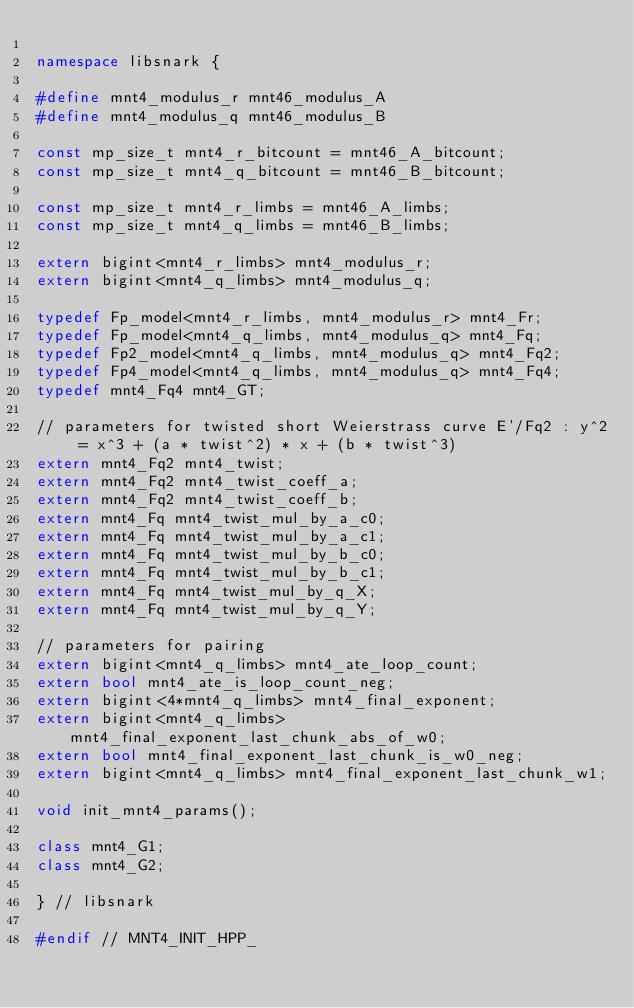<code> <loc_0><loc_0><loc_500><loc_500><_C++_>
namespace libsnark {

#define mnt4_modulus_r mnt46_modulus_A
#define mnt4_modulus_q mnt46_modulus_B

const mp_size_t mnt4_r_bitcount = mnt46_A_bitcount;
const mp_size_t mnt4_q_bitcount = mnt46_B_bitcount;

const mp_size_t mnt4_r_limbs = mnt46_A_limbs;
const mp_size_t mnt4_q_limbs = mnt46_B_limbs;

extern bigint<mnt4_r_limbs> mnt4_modulus_r;
extern bigint<mnt4_q_limbs> mnt4_modulus_q;

typedef Fp_model<mnt4_r_limbs, mnt4_modulus_r> mnt4_Fr;
typedef Fp_model<mnt4_q_limbs, mnt4_modulus_q> mnt4_Fq;
typedef Fp2_model<mnt4_q_limbs, mnt4_modulus_q> mnt4_Fq2;
typedef Fp4_model<mnt4_q_limbs, mnt4_modulus_q> mnt4_Fq4;
typedef mnt4_Fq4 mnt4_GT;

// parameters for twisted short Weierstrass curve E'/Fq2 : y^2 = x^3 + (a * twist^2) * x + (b * twist^3)
extern mnt4_Fq2 mnt4_twist;
extern mnt4_Fq2 mnt4_twist_coeff_a;
extern mnt4_Fq2 mnt4_twist_coeff_b;
extern mnt4_Fq mnt4_twist_mul_by_a_c0;
extern mnt4_Fq mnt4_twist_mul_by_a_c1;
extern mnt4_Fq mnt4_twist_mul_by_b_c0;
extern mnt4_Fq mnt4_twist_mul_by_b_c1;
extern mnt4_Fq mnt4_twist_mul_by_q_X;
extern mnt4_Fq mnt4_twist_mul_by_q_Y;

// parameters for pairing
extern bigint<mnt4_q_limbs> mnt4_ate_loop_count;
extern bool mnt4_ate_is_loop_count_neg;
extern bigint<4*mnt4_q_limbs> mnt4_final_exponent;
extern bigint<mnt4_q_limbs> mnt4_final_exponent_last_chunk_abs_of_w0;
extern bool mnt4_final_exponent_last_chunk_is_w0_neg;
extern bigint<mnt4_q_limbs> mnt4_final_exponent_last_chunk_w1;

void init_mnt4_params();

class mnt4_G1;
class mnt4_G2;

} // libsnark

#endif // MNT4_INIT_HPP_
</code> 